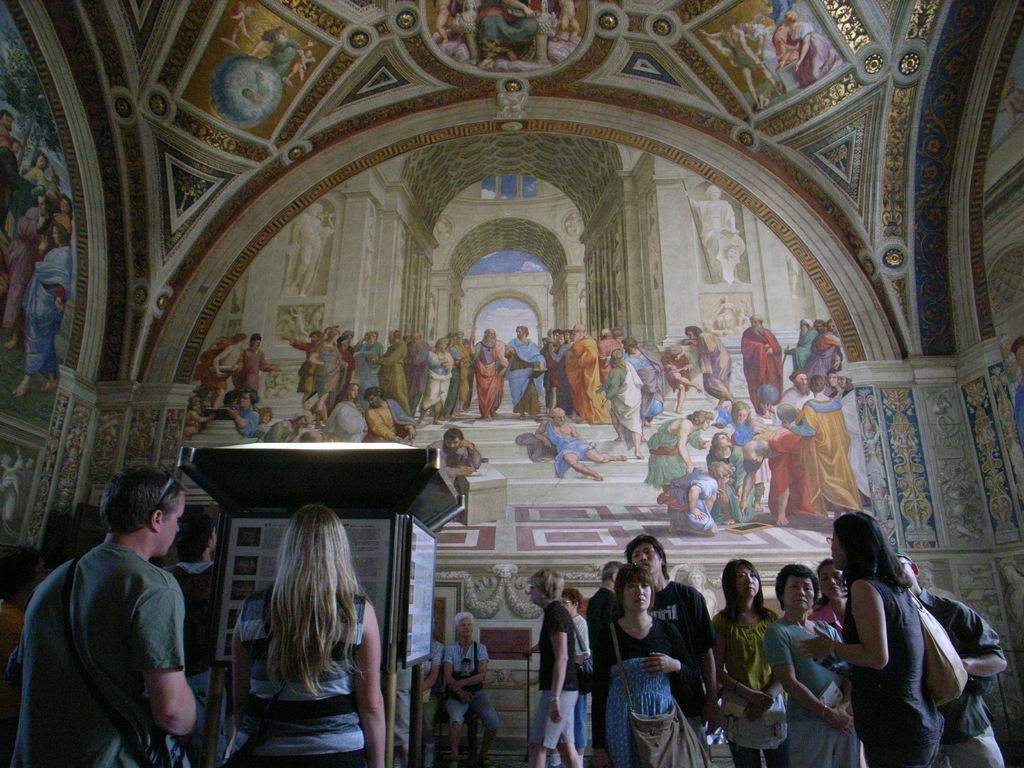Describe this image in one or two sentences. This image is taken inside the church. In this image we can see some persons standing and few are sitting. There is an object with text boards. 